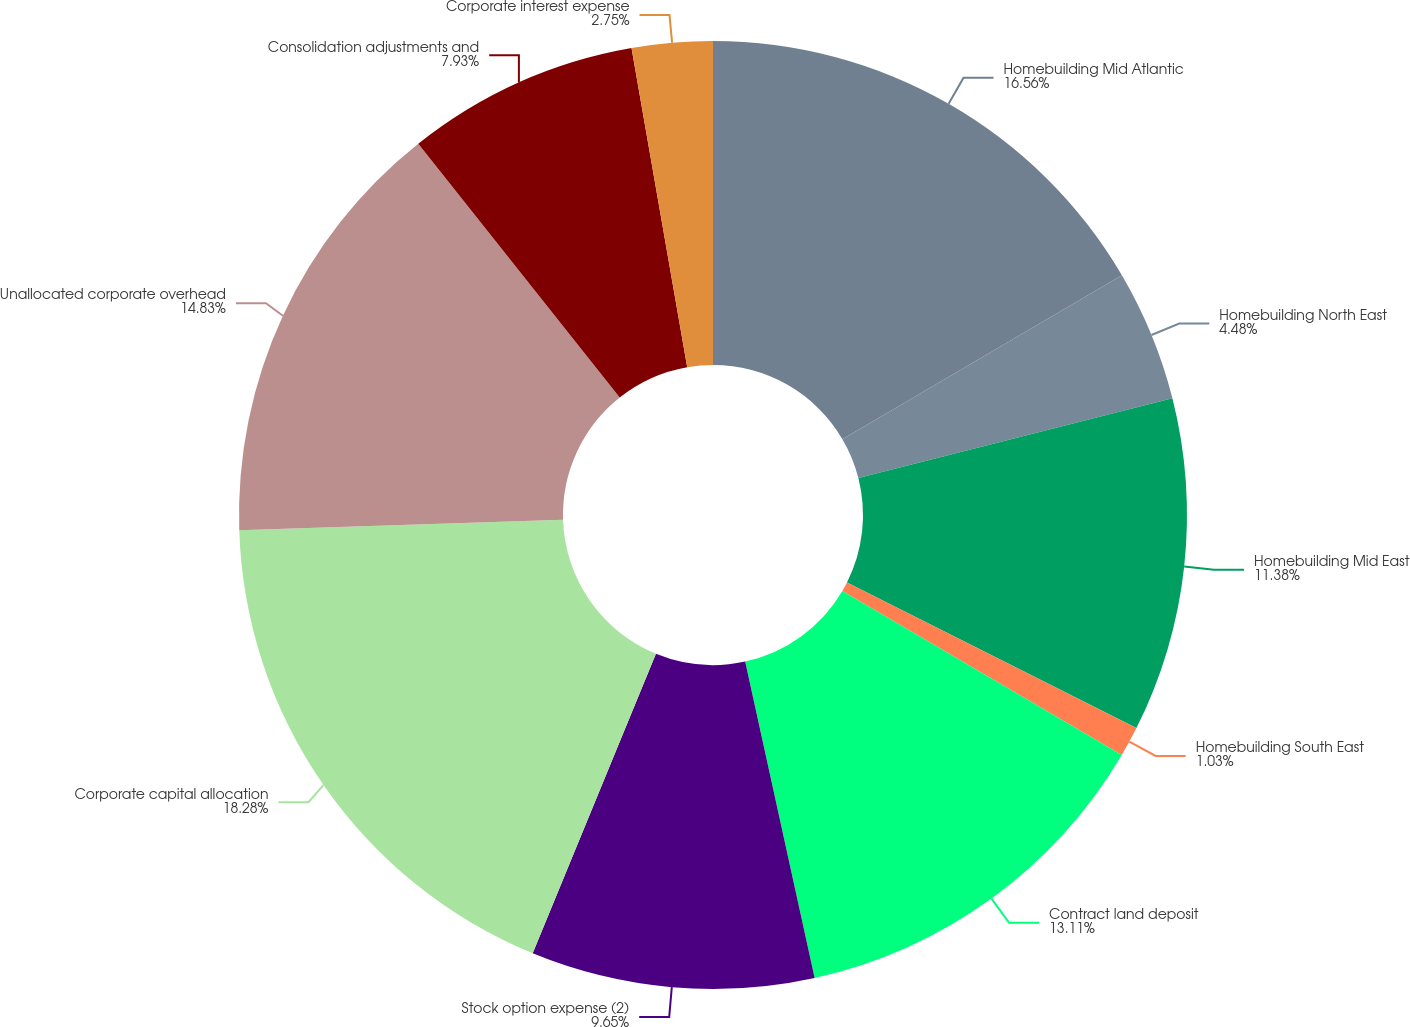<chart> <loc_0><loc_0><loc_500><loc_500><pie_chart><fcel>Homebuilding Mid Atlantic<fcel>Homebuilding North East<fcel>Homebuilding Mid East<fcel>Homebuilding South East<fcel>Contract land deposit<fcel>Stock option expense (2)<fcel>Corporate capital allocation<fcel>Unallocated corporate overhead<fcel>Consolidation adjustments and<fcel>Corporate interest expense<nl><fcel>16.56%<fcel>4.48%<fcel>11.38%<fcel>1.03%<fcel>13.11%<fcel>9.65%<fcel>18.28%<fcel>14.83%<fcel>7.93%<fcel>2.75%<nl></chart> 